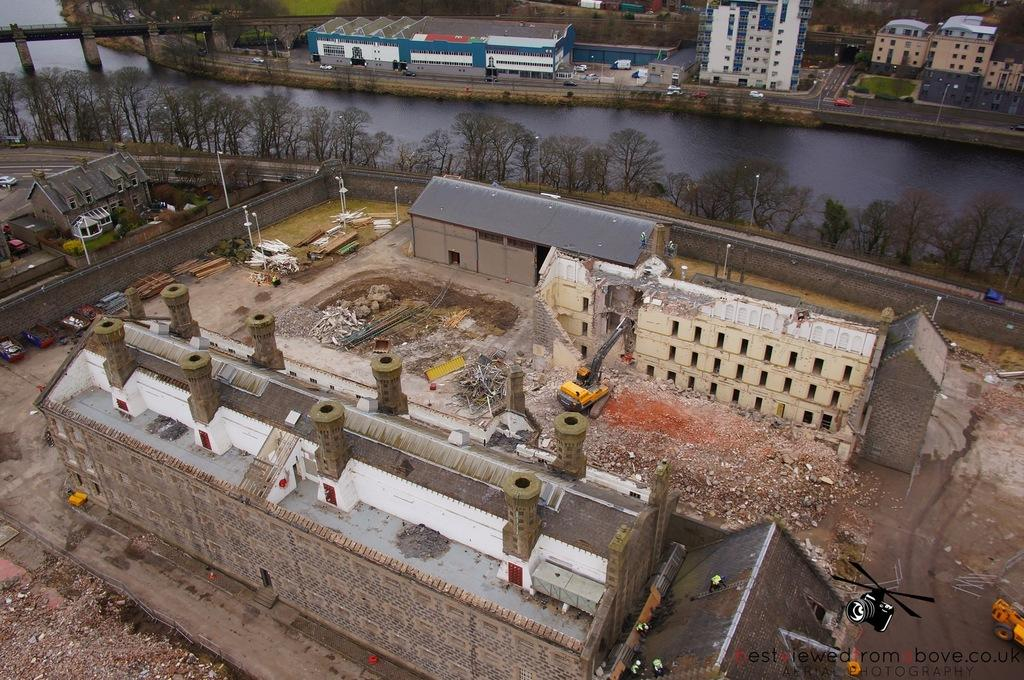What type of structures can be seen in the image? There are buildings in the image. What natural elements are present in the image? There are trees in the image. What man-made objects can be seen in the image? There are vehicles in the image. What body of water is visible in the image? There is water visible in the image. Who is the owner of the wrist in the image? There is no wrist visible in the image. How does the heat affect the buildings in the image? There is no information about the temperature or heat in the image, so we cannot determine its effect on the buildings. 